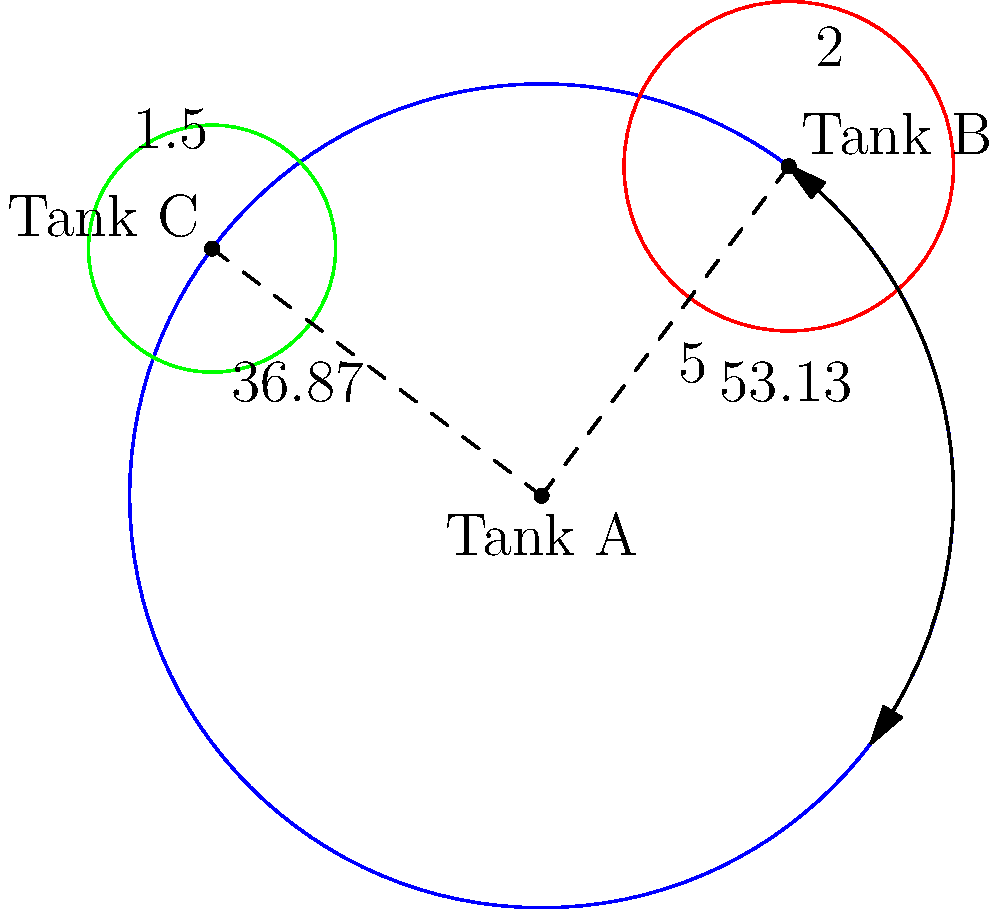In a fuel storage facility, three circular tanks (A, B, and C) are positioned as shown in the diagram. Tank A has a radius of 5 units and is located at the origin. Tank B has a radius of 2 units and is located at $(3,4)$ in Cartesian coordinates. Tank C has a radius of 1.5 units. Given that the minimum safe distance between the edges of any two tanks should be 2 units, determine the polar coordinates $(r,\theta)$ of Tank C. Round your answer to two decimal places. To solve this problem, we'll follow these steps:

1) First, let's convert the position of Tank B from Cartesian to polar coordinates:
   $r = \sqrt{3^2 + 4^2} = 5$
   $\theta = \tan^{-1}(\frac{4}{3}) \approx 53.13°$

2) The distance between the centers of Tank A and Tank B is 5 units. The minimum safe distance between their edges is:
   $5 - (5 + 2 + 2) = -4$ units
   This is negative, meaning the tanks overlap, which is not safe.

3) For Tank C, we need to ensure it's at least 2 units away from both Tank A and Tank B.

4) The minimum distance from the center of Tank A to the center of Tank C should be:
   $5 + 1.5 + 2 = 8.5$ units

5) The minimum distance from the center of Tank B to the center of Tank C should be:
   $2 + 1.5 + 2 = 5.5$ units

6) To satisfy both conditions, Tank C should be placed at the intersection of two circles:
   - One centered at (0,0) with radius 8.5
   - Another centered at (3,4) with radius 5.5

7) This intersection point can be calculated to be approximately $(-4, 3)$ in Cartesian coordinates.

8) Converting this to polar coordinates:
   $r = \sqrt{(-4)^2 + 3^2} = 5$
   $\theta = \tan^{-1}(\frac{3}{-4}) + 180° \approx 323.13°$ (we add 180° because it's in the third quadrant)

9) Rounding to two decimal places: $r = 5.00$, $\theta = 323.13°$
Answer: $(5.00, 323.13°)$ 